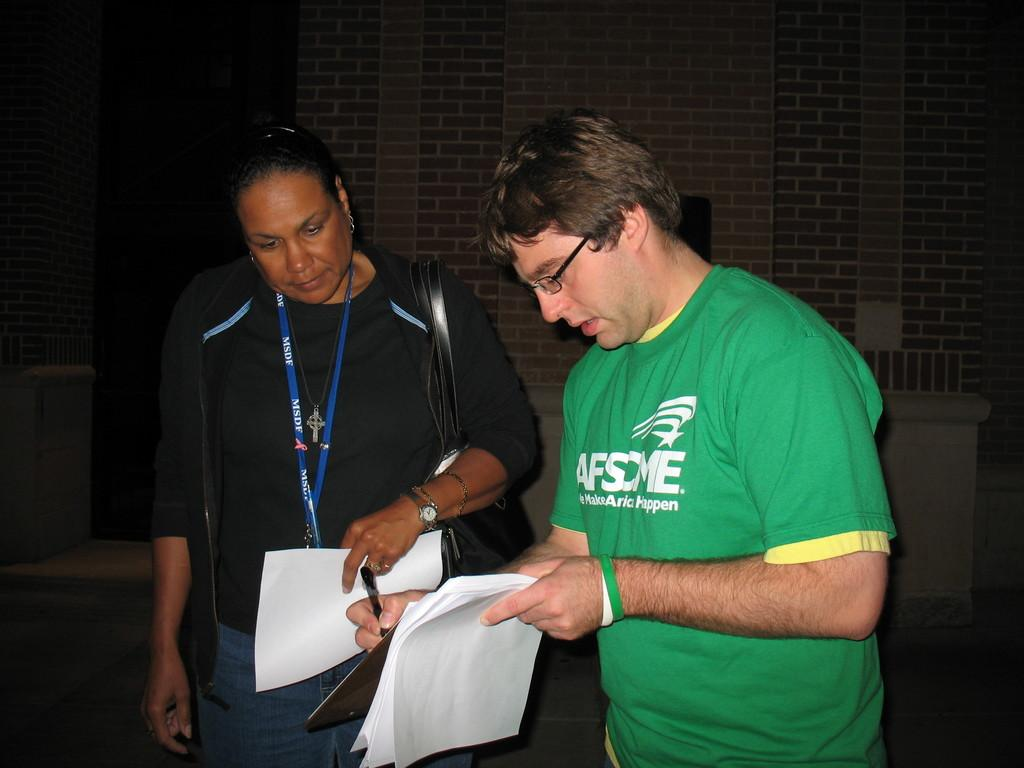How many people are in the image? There are two persons in the image. What are the persons doing in the image? The persons are standing and holding papers. What else are the persons holding in the image? The persons are also holding pens. What can be seen behind the persons in the image? There is a wall behind the persons. What type of insect can be seen crawling on the wall behind the persons? There is no insect visible on the wall behind the persons in the image. 